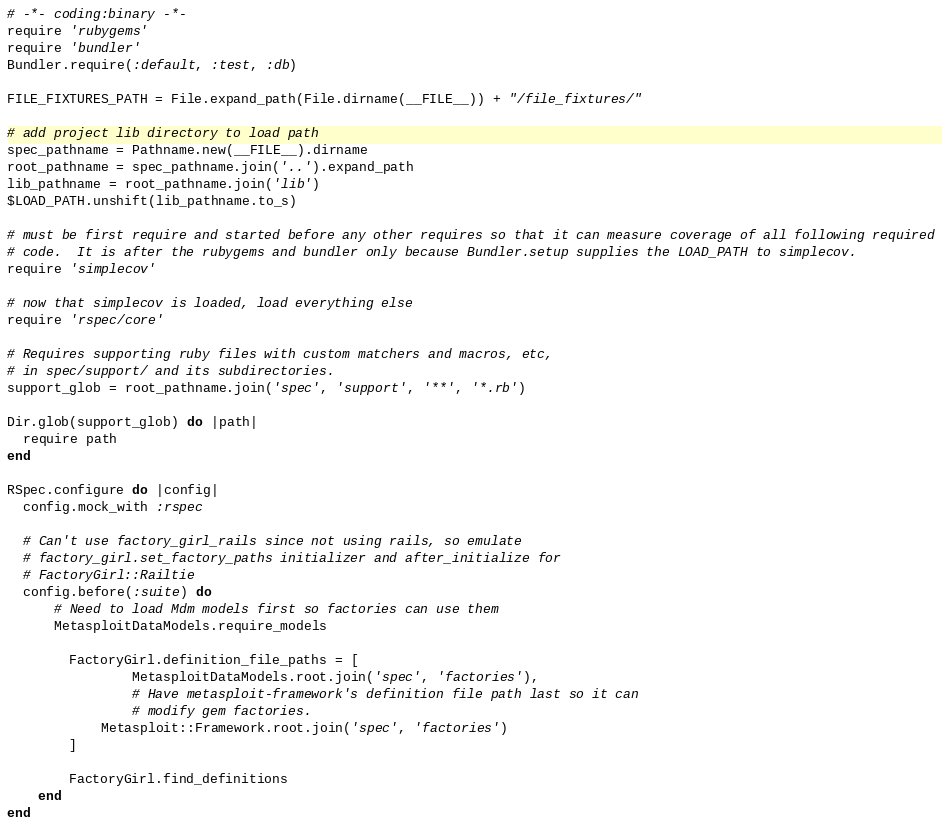Convert code to text. <code><loc_0><loc_0><loc_500><loc_500><_Ruby_># -*- coding:binary -*-
require 'rubygems'
require 'bundler'
Bundler.require(:default, :test, :db)

FILE_FIXTURES_PATH = File.expand_path(File.dirname(__FILE__)) + "/file_fixtures/"

# add project lib directory to load path
spec_pathname = Pathname.new(__FILE__).dirname
root_pathname = spec_pathname.join('..').expand_path
lib_pathname = root_pathname.join('lib')
$LOAD_PATH.unshift(lib_pathname.to_s)

# must be first require and started before any other requires so that it can measure coverage of all following required
# code.  It is after the rubygems and bundler only because Bundler.setup supplies the LOAD_PATH to simplecov.
require 'simplecov'

# now that simplecov is loaded, load everything else
require 'rspec/core'

# Requires supporting ruby files with custom matchers and macros, etc,
# in spec/support/ and its subdirectories.
support_glob = root_pathname.join('spec', 'support', '**', '*.rb')

Dir.glob(support_glob) do |path|
  require path
end

RSpec.configure do |config|
  config.mock_with :rspec

  # Can't use factory_girl_rails since not using rails, so emulate
  # factory_girl.set_factory_paths initializer and after_initialize for
  # FactoryGirl::Railtie
  config.before(:suite) do
	  # Need to load Mdm models first so factories can use them
	  MetasploitDataModels.require_models

		FactoryGirl.definition_file_paths = [
				MetasploitDataModels.root.join('spec', 'factories'),
				# Have metasploit-framework's definition file path last so it can
				# modify gem factories.
		    Metasploit::Framework.root.join('spec', 'factories')
		]

		FactoryGirl.find_definitions
	end
end

</code> 